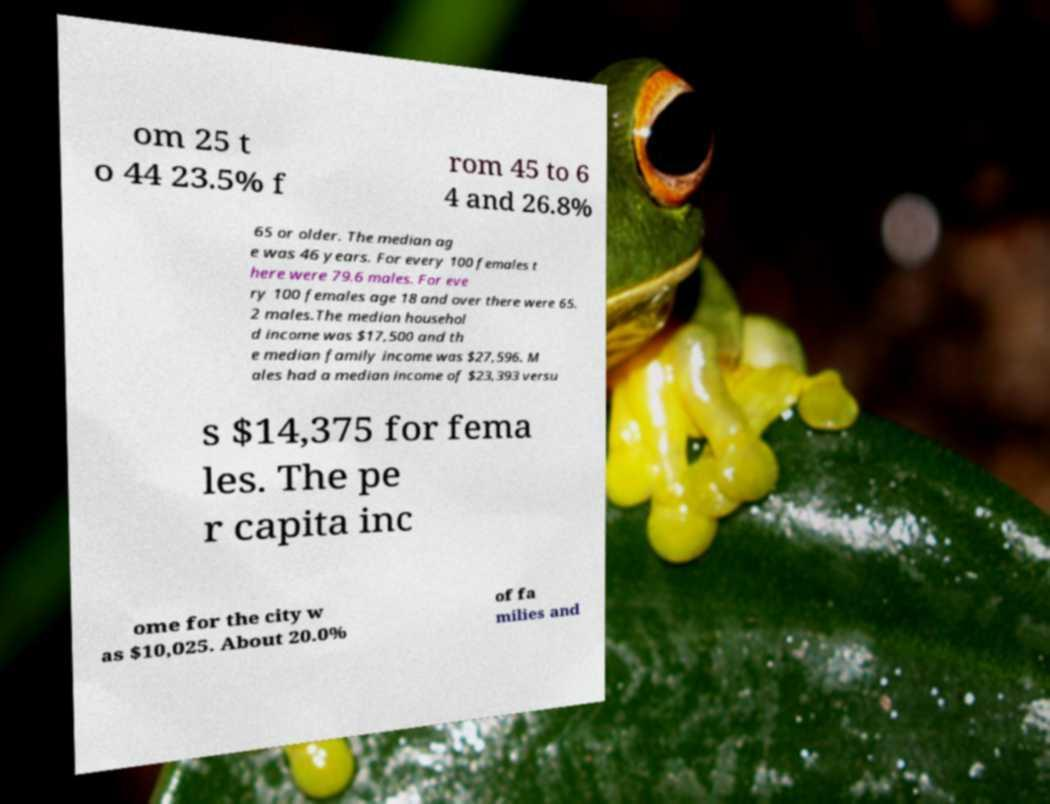Could you assist in decoding the text presented in this image and type it out clearly? om 25 t o 44 23.5% f rom 45 to 6 4 and 26.8% 65 or older. The median ag e was 46 years. For every 100 females t here were 79.6 males. For eve ry 100 females age 18 and over there were 65. 2 males.The median househol d income was $17,500 and th e median family income was $27,596. M ales had a median income of $23,393 versu s $14,375 for fema les. The pe r capita inc ome for the city w as $10,025. About 20.0% of fa milies and 